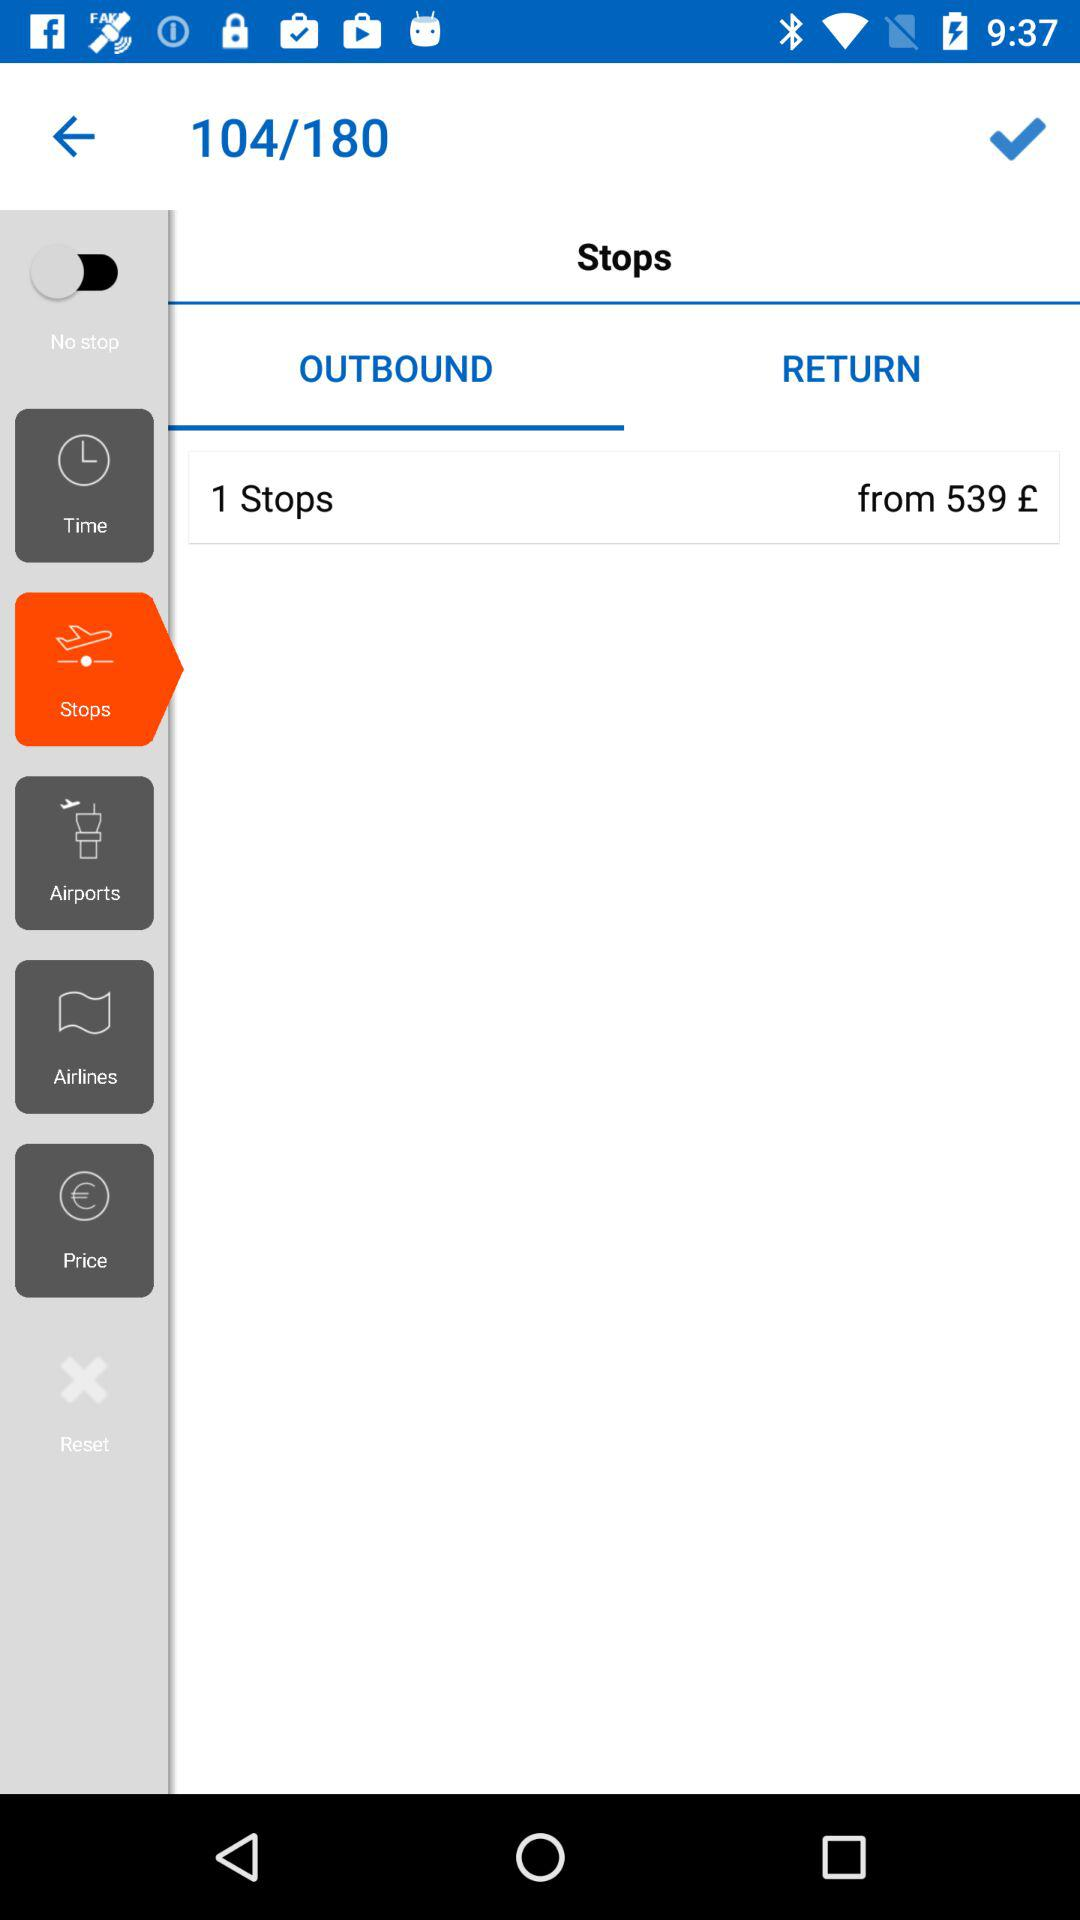Which tab is selected? The selected tab is "OUTBOUND". 